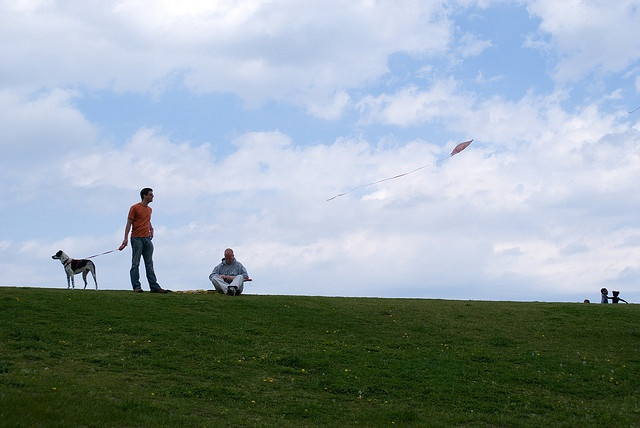Describe the objects in this image and their specific colors. I can see people in lavender, black, maroon, darkblue, and gray tones, people in lavender, gray, black, and darkgray tones, dog in lavender, black, gray, and darkgray tones, kite in lavender, darkgray, and gray tones, and people in lavender, black, navy, gray, and lightblue tones in this image. 